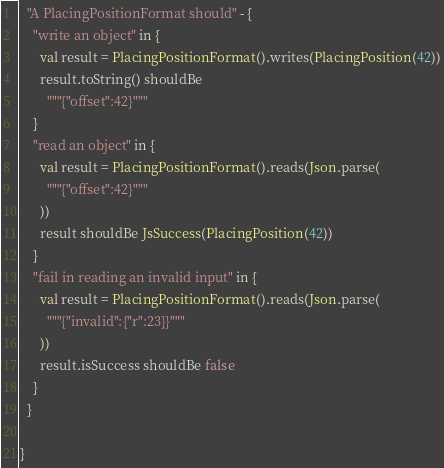<code> <loc_0><loc_0><loc_500><loc_500><_Scala_>  "A PlacingPositionFormat should" - {
    "write an object" in {
      val result = PlacingPositionFormat().writes(PlacingPosition(42))
      result.toString() shouldBe
        """{"offset":42}"""
    }
    "read an object" in {
      val result = PlacingPositionFormat().reads(Json.parse(
        """{"offset":42}"""
      ))
      result shouldBe JsSuccess(PlacingPosition(42))
    }
    "fail in reading an invalid input" in {
      val result = PlacingPositionFormat().reads(Json.parse(
        """{"invalid":{"r":23}}"""
      ))
      result.isSuccess shouldBe false
    }
  }

}
</code> 